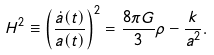Convert formula to latex. <formula><loc_0><loc_0><loc_500><loc_500>H ^ { 2 } \equiv \left ( \frac { \dot { a } ( t ) } { a ( t ) } \right ) ^ { 2 } = \frac { 8 \pi G } { 3 } \rho - \frac { k } { a ^ { 2 } } .</formula> 